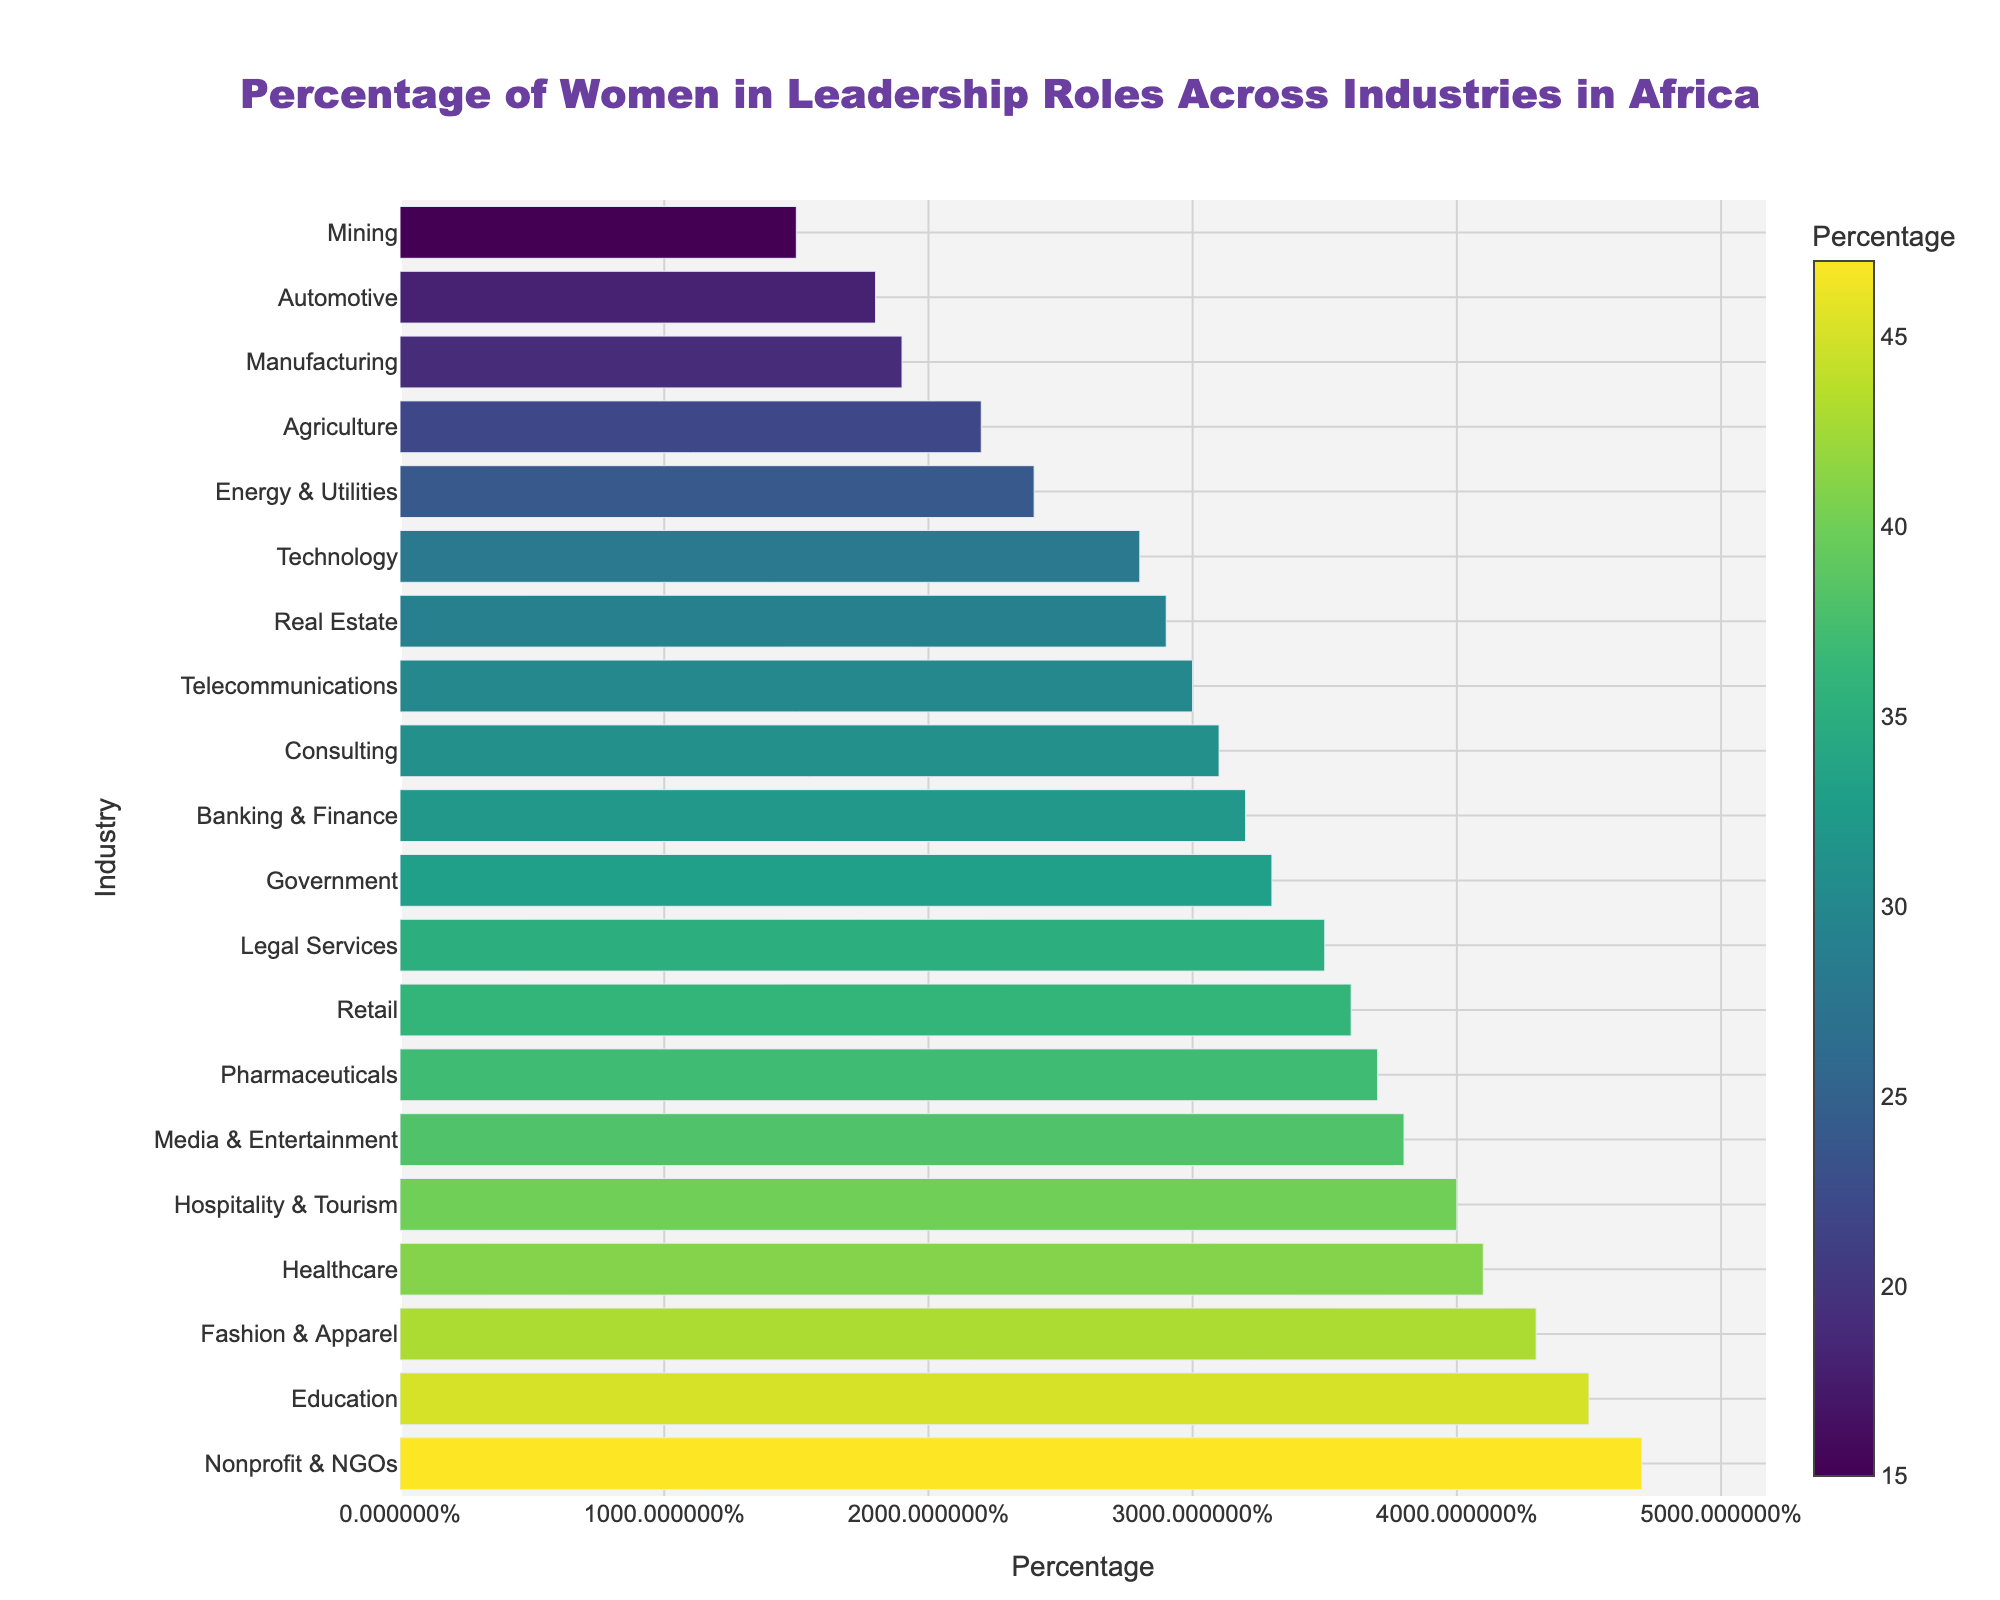what industry has the highest percentage of women in leadership roles? The chart shows the percentages of women in leadership roles across various industries. The industry with the highest bar represents the highest percentage. From the chart, Nonprofit & NGOs is at the top with a percentage of 47%.
Answer: Nonprofit & NGOs what is the percentage difference between the healthcare and automotive industries? Locate the bars for Healthcare and Automotive industries. The percentages are 41% and 18%, respectively. Subtract the lower value from the higher value: 41% - 18% = 23%.
Answer: 23% which has a higher percentage of women in leadership roles, banking & finance or telecommunications? Compare the lengths of the bars for Banking & Finance and Telecommunications. Banking & Finance is at 32%, and Telecommunications is at 30%. Since 32% is higher than 30%, Banking & Finance has a higher percentage.
Answer: Banking & Finance what is the average percentage of women in leadership roles in healthcare, education, and hospitality & tourism? Average = (sum of individual percentages) / (number of industries). Calculate the individual percentages: Healthcare = 41%, Education = 45%, Hospitality & Tourism = 40%. Sum them up: 41 + 45 + 40 = 126. Divide by 3: 126 / 3 = 42%.
Answer: 42% how many industries have a percentage of women in leadership roles above 35%? Identify and count the bars taller than the 35% mark. The industries are: Healthcare (41%), Education (45%), Retail (36%), Media & Entertainment (38%), Nonprofit & NGOs (47%), Hospitality & Tourism (40%), Pharmaceuticals (37%), and Fashion & Apparel (43%). There are 8 bars.
Answer: 8 what is the median percentage of women in leadership roles across all industries? List the percentages in ascending order: 15, 18, 19, 22, 24, 28, 29, 30, 31, 32, 33, 35, 36, 37, 38, 40, 41, 43, 45, 47. The median is the middle value in this ordered list. Since there are 20 values, the median is the average of the 10th and 11th values: (32 + 33) / 2 = 32.5%.
Answer: 32.5% are there industries with the same percentage of women in leadership roles? If so, which industries? Look for bars with matching lengths. Two industries have the same percentage of 29%: Technology and Real Estate.
Answer: Technology and Real Estate in which industry is the percentage of women in leadership roles closest to 30%? Locate the industry bars around the 30% mark: Technology (28%), Real Estate (29%), Telecommunications (30%), Consulting (31%), Government (33%). The industry closest to 30% is Telecommunications at exactly 30%.
Answer: Telecommunications 